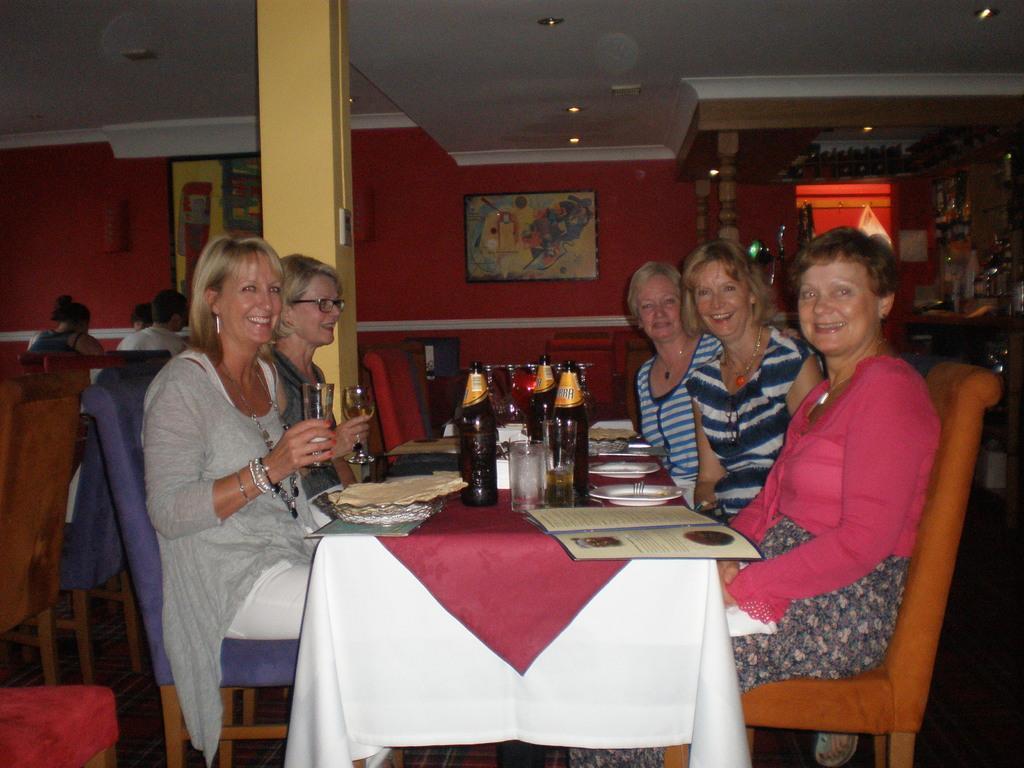Could you give a brief overview of what you see in this image? In this picture we can see some persons are sitting on the chairs. This is the table. On the table there are some bottles, glasses, and plates. On the background there is a red colored wall. These are the lights. And there are some frames on the wall. 